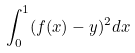<formula> <loc_0><loc_0><loc_500><loc_500>\int _ { 0 } ^ { 1 } ( f ( x ) - y ) ^ { 2 } d x</formula> 